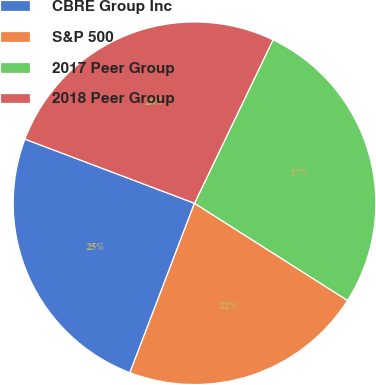Convert chart. <chart><loc_0><loc_0><loc_500><loc_500><pie_chart><fcel>CBRE Group Inc<fcel>S&P 500<fcel>2017 Peer Group<fcel>2018 Peer Group<nl><fcel>24.96%<fcel>21.79%<fcel>26.88%<fcel>26.37%<nl></chart> 